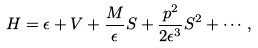<formula> <loc_0><loc_0><loc_500><loc_500>H = \epsilon + V + \frac { M } { \epsilon } S + \frac { { p } ^ { 2 } } { 2 \epsilon ^ { 3 } } S ^ { 2 } + \cdots ,</formula> 